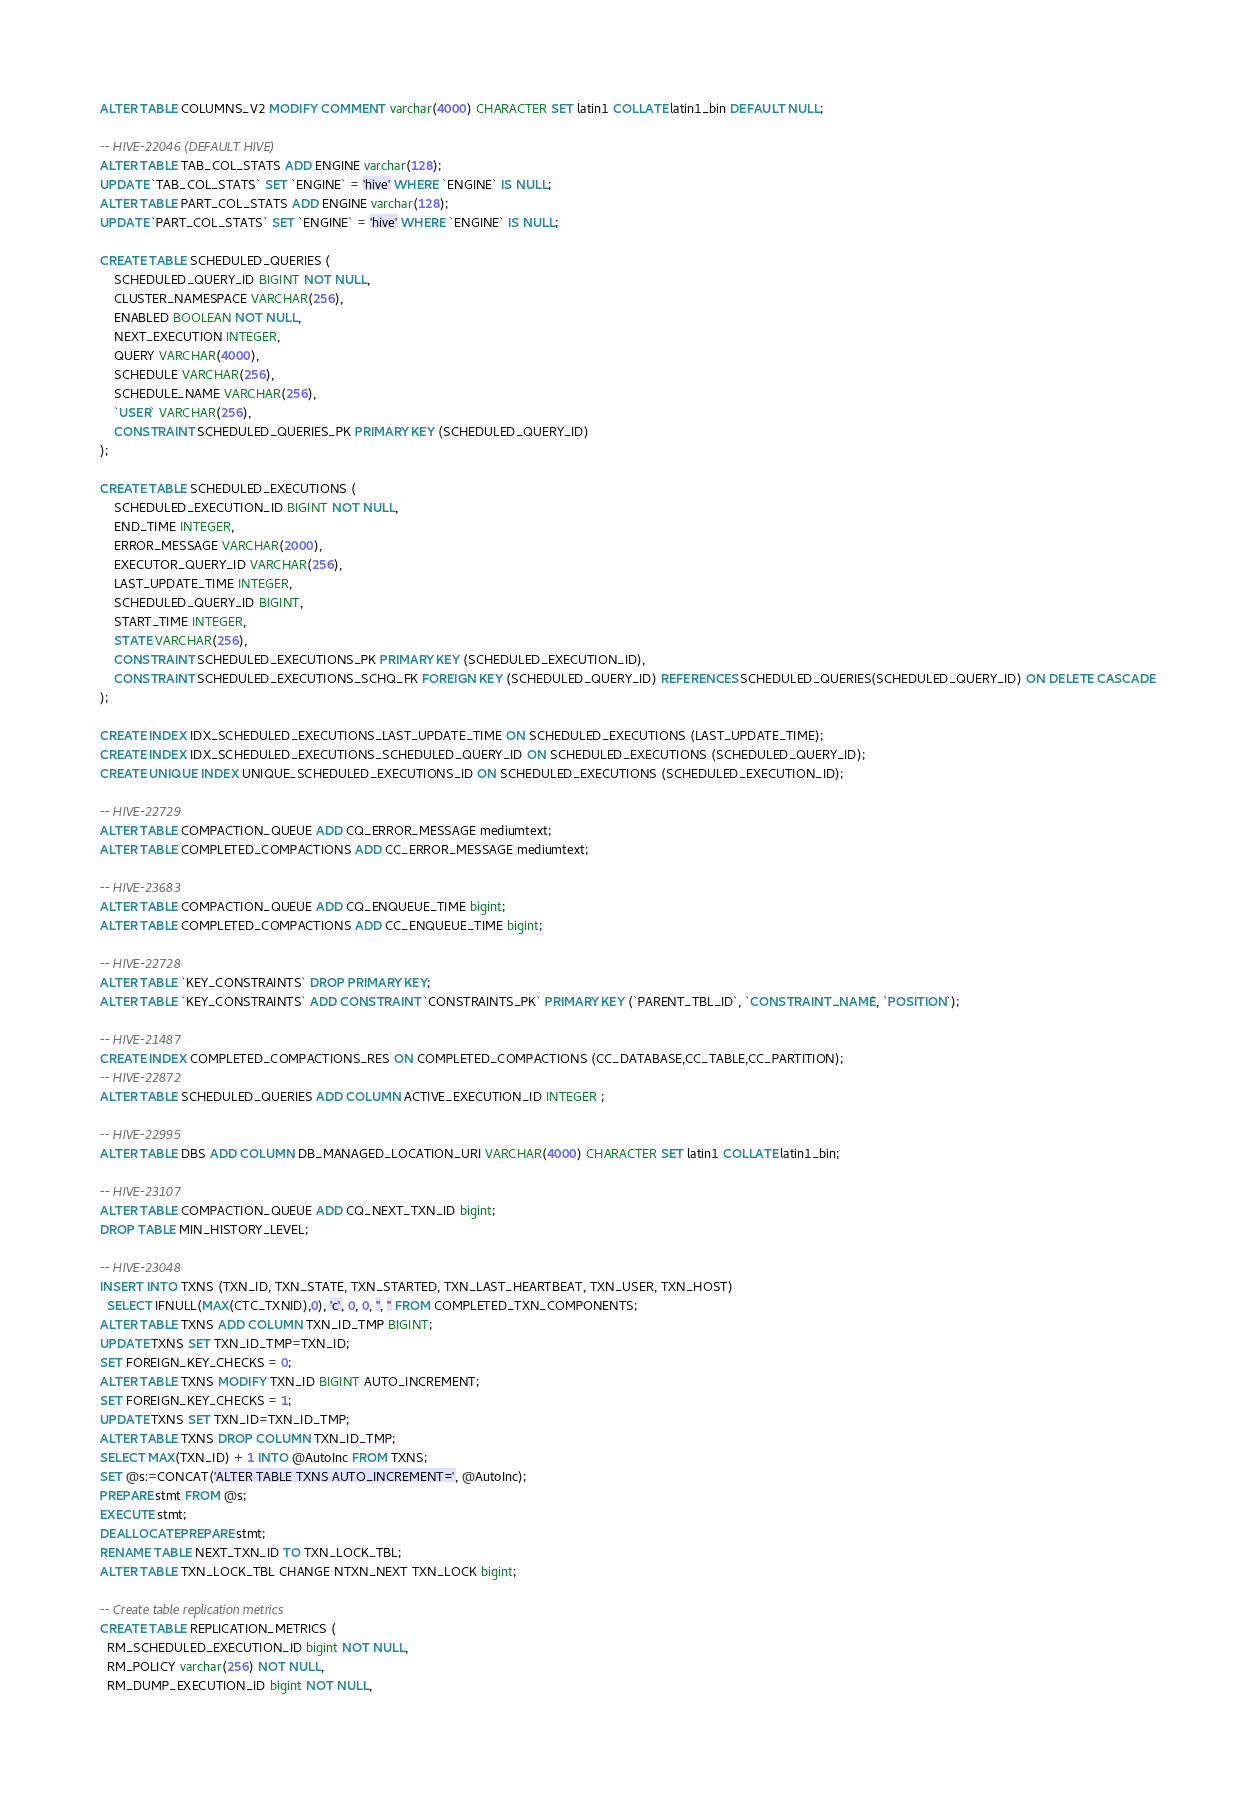Convert code to text. <code><loc_0><loc_0><loc_500><loc_500><_SQL_>ALTER TABLE COLUMNS_V2 MODIFY COMMENT varchar(4000) CHARACTER SET latin1 COLLATE latin1_bin DEFAULT NULL;

-- HIVE-22046 (DEFAULT HIVE)
ALTER TABLE TAB_COL_STATS ADD ENGINE varchar(128);
UPDATE `TAB_COL_STATS` SET `ENGINE` = 'hive' WHERE `ENGINE` IS NULL;
ALTER TABLE PART_COL_STATS ADD ENGINE varchar(128);
UPDATE `PART_COL_STATS` SET `ENGINE` = 'hive' WHERE `ENGINE` IS NULL;

CREATE TABLE SCHEDULED_QUERIES (
	SCHEDULED_QUERY_ID BIGINT NOT NULL,
	CLUSTER_NAMESPACE VARCHAR(256),
	ENABLED BOOLEAN NOT NULL,
	NEXT_EXECUTION INTEGER,
	QUERY VARCHAR(4000),
	SCHEDULE VARCHAR(256),
	SCHEDULE_NAME VARCHAR(256),
	`USER` VARCHAR(256),
	CONSTRAINT SCHEDULED_QUERIES_PK PRIMARY KEY (SCHEDULED_QUERY_ID)
);

CREATE TABLE SCHEDULED_EXECUTIONS (
	SCHEDULED_EXECUTION_ID BIGINT NOT NULL,
	END_TIME INTEGER,
	ERROR_MESSAGE VARCHAR(2000),
	EXECUTOR_QUERY_ID VARCHAR(256),
	LAST_UPDATE_TIME INTEGER,
	SCHEDULED_QUERY_ID BIGINT,
	START_TIME INTEGER,
	STATE VARCHAR(256),
	CONSTRAINT SCHEDULED_EXECUTIONS_PK PRIMARY KEY (SCHEDULED_EXECUTION_ID),
	CONSTRAINT SCHEDULED_EXECUTIONS_SCHQ_FK FOREIGN KEY (SCHEDULED_QUERY_ID) REFERENCES SCHEDULED_QUERIES(SCHEDULED_QUERY_ID) ON DELETE CASCADE
);

CREATE INDEX IDX_SCHEDULED_EXECUTIONS_LAST_UPDATE_TIME ON SCHEDULED_EXECUTIONS (LAST_UPDATE_TIME);
CREATE INDEX IDX_SCHEDULED_EXECUTIONS_SCHEDULED_QUERY_ID ON SCHEDULED_EXECUTIONS (SCHEDULED_QUERY_ID);
CREATE UNIQUE INDEX UNIQUE_SCHEDULED_EXECUTIONS_ID ON SCHEDULED_EXECUTIONS (SCHEDULED_EXECUTION_ID);

-- HIVE-22729
ALTER TABLE COMPACTION_QUEUE ADD CQ_ERROR_MESSAGE mediumtext;
ALTER TABLE COMPLETED_COMPACTIONS ADD CC_ERROR_MESSAGE mediumtext;

-- HIVE-23683
ALTER TABLE COMPACTION_QUEUE ADD CQ_ENQUEUE_TIME bigint;
ALTER TABLE COMPLETED_COMPACTIONS ADD CC_ENQUEUE_TIME bigint;

-- HIVE-22728
ALTER TABLE `KEY_CONSTRAINTS` DROP PRIMARY KEY;
ALTER TABLE `KEY_CONSTRAINTS` ADD CONSTRAINT `CONSTRAINTS_PK` PRIMARY KEY (`PARENT_TBL_ID`, `CONSTRAINT_NAME`, `POSITION`);

-- HIVE-21487
CREATE INDEX COMPLETED_COMPACTIONS_RES ON COMPLETED_COMPACTIONS (CC_DATABASE,CC_TABLE,CC_PARTITION);
-- HIVE-22872
ALTER TABLE SCHEDULED_QUERIES ADD COLUMN ACTIVE_EXECUTION_ID INTEGER ;

-- HIVE-22995
ALTER TABLE DBS ADD COLUMN DB_MANAGED_LOCATION_URI VARCHAR(4000) CHARACTER SET latin1 COLLATE latin1_bin;

-- HIVE-23107
ALTER TABLE COMPACTION_QUEUE ADD CQ_NEXT_TXN_ID bigint;
DROP TABLE MIN_HISTORY_LEVEL;

-- HIVE-23048
INSERT INTO TXNS (TXN_ID, TXN_STATE, TXN_STARTED, TXN_LAST_HEARTBEAT, TXN_USER, TXN_HOST)
  SELECT IFNULL(MAX(CTC_TXNID),0), 'c', 0, 0, '', '' FROM COMPLETED_TXN_COMPONENTS;
ALTER TABLE TXNS ADD COLUMN TXN_ID_TMP BIGINT;
UPDATE TXNS SET TXN_ID_TMP=TXN_ID;
SET FOREIGN_KEY_CHECKS = 0;
ALTER TABLE TXNS MODIFY TXN_ID BIGINT AUTO_INCREMENT;
SET FOREIGN_KEY_CHECKS = 1;
UPDATE TXNS SET TXN_ID=TXN_ID_TMP;
ALTER TABLE TXNS DROP COLUMN TXN_ID_TMP;
SELECT MAX(TXN_ID) + 1 INTO @AutoInc FROM TXNS;
SET @s:=CONCAT('ALTER TABLE TXNS AUTO_INCREMENT=', @AutoInc);
PREPARE stmt FROM @s;
EXECUTE stmt;
DEALLOCATE PREPARE stmt;
RENAME TABLE NEXT_TXN_ID TO TXN_LOCK_TBL;
ALTER TABLE TXN_LOCK_TBL CHANGE NTXN_NEXT TXN_LOCK bigint;

-- Create table replication metrics
CREATE TABLE REPLICATION_METRICS (
  RM_SCHEDULED_EXECUTION_ID bigint NOT NULL,
  RM_POLICY varchar(256) NOT NULL,
  RM_DUMP_EXECUTION_ID bigint NOT NULL,</code> 